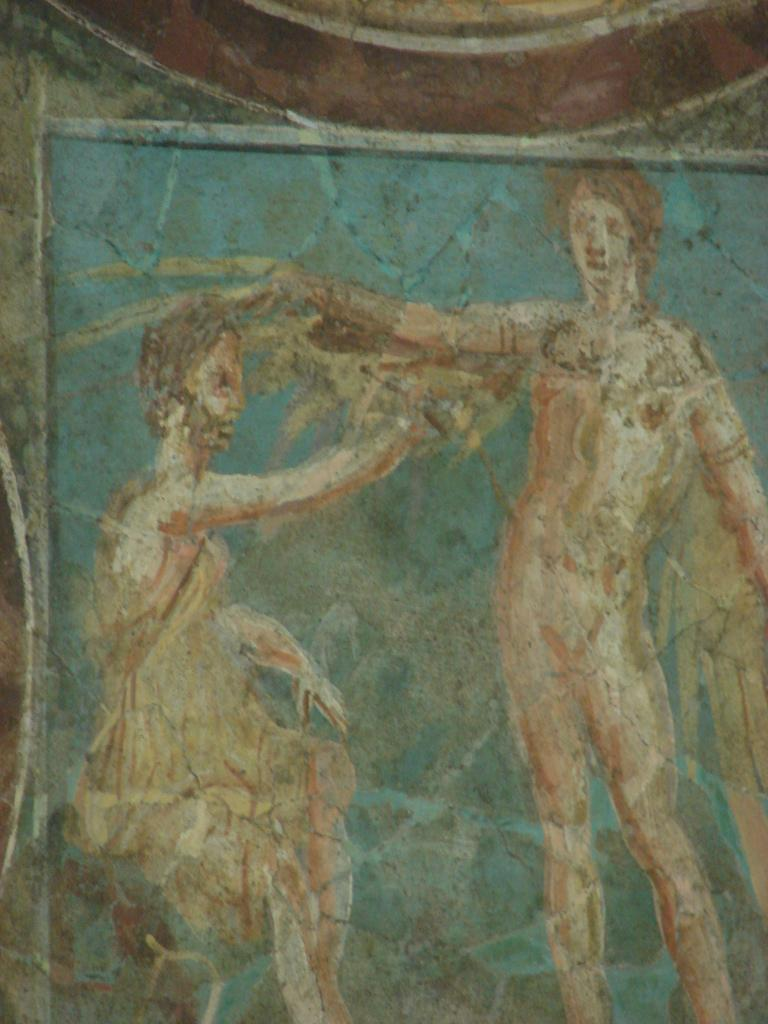What is on the wall in the image? There is a painting on the wall in the image. How many trees are depicted in the painting on the wall? There is no information about the content of the painting, so it is impossible to determine how many trees are depicted in it. 